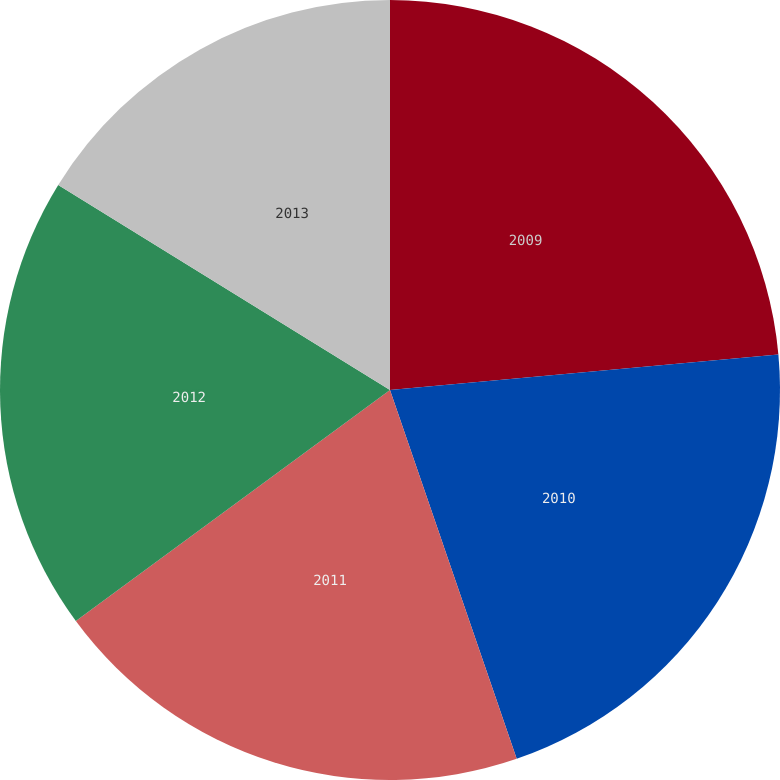<chart> <loc_0><loc_0><loc_500><loc_500><pie_chart><fcel>2009<fcel>2010<fcel>2011<fcel>2012<fcel>2013<nl><fcel>23.55%<fcel>21.18%<fcel>20.17%<fcel>18.9%<fcel>16.19%<nl></chart> 